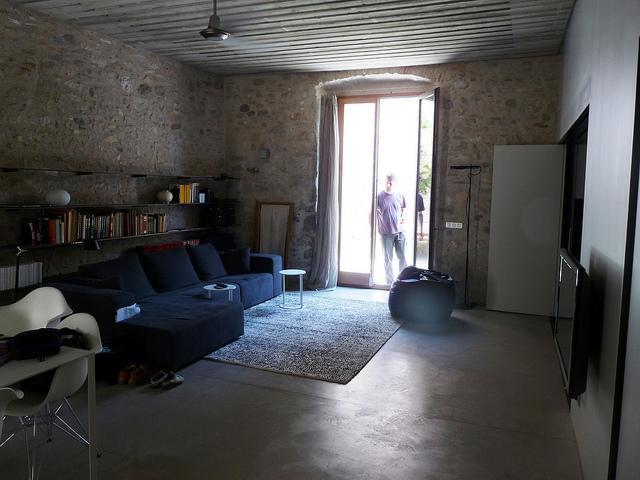How many chairs can you see?
Give a very brief answer. 2. 